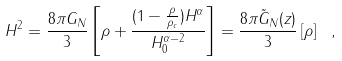<formula> <loc_0><loc_0><loc_500><loc_500>H ^ { 2 } = \frac { 8 \pi G _ { N } } { 3 } \left [ \rho + \frac { ( 1 - \frac { \rho } { \rho _ { c } } ) H ^ { \alpha } } { H _ { 0 } ^ { \alpha - 2 } } \right ] = \frac { 8 \pi \tilde { G } _ { N } ( z ) } { 3 } \left [ \rho \right ] \ ,</formula> 